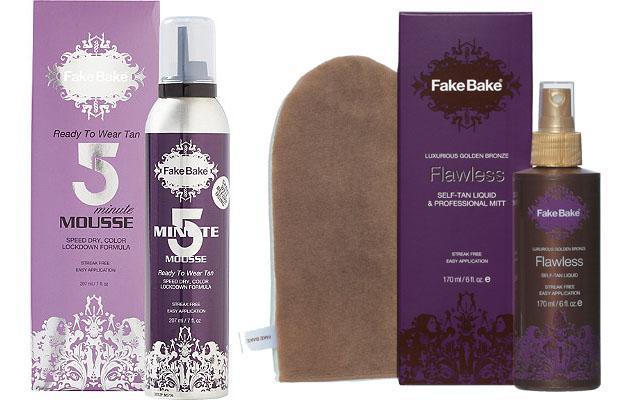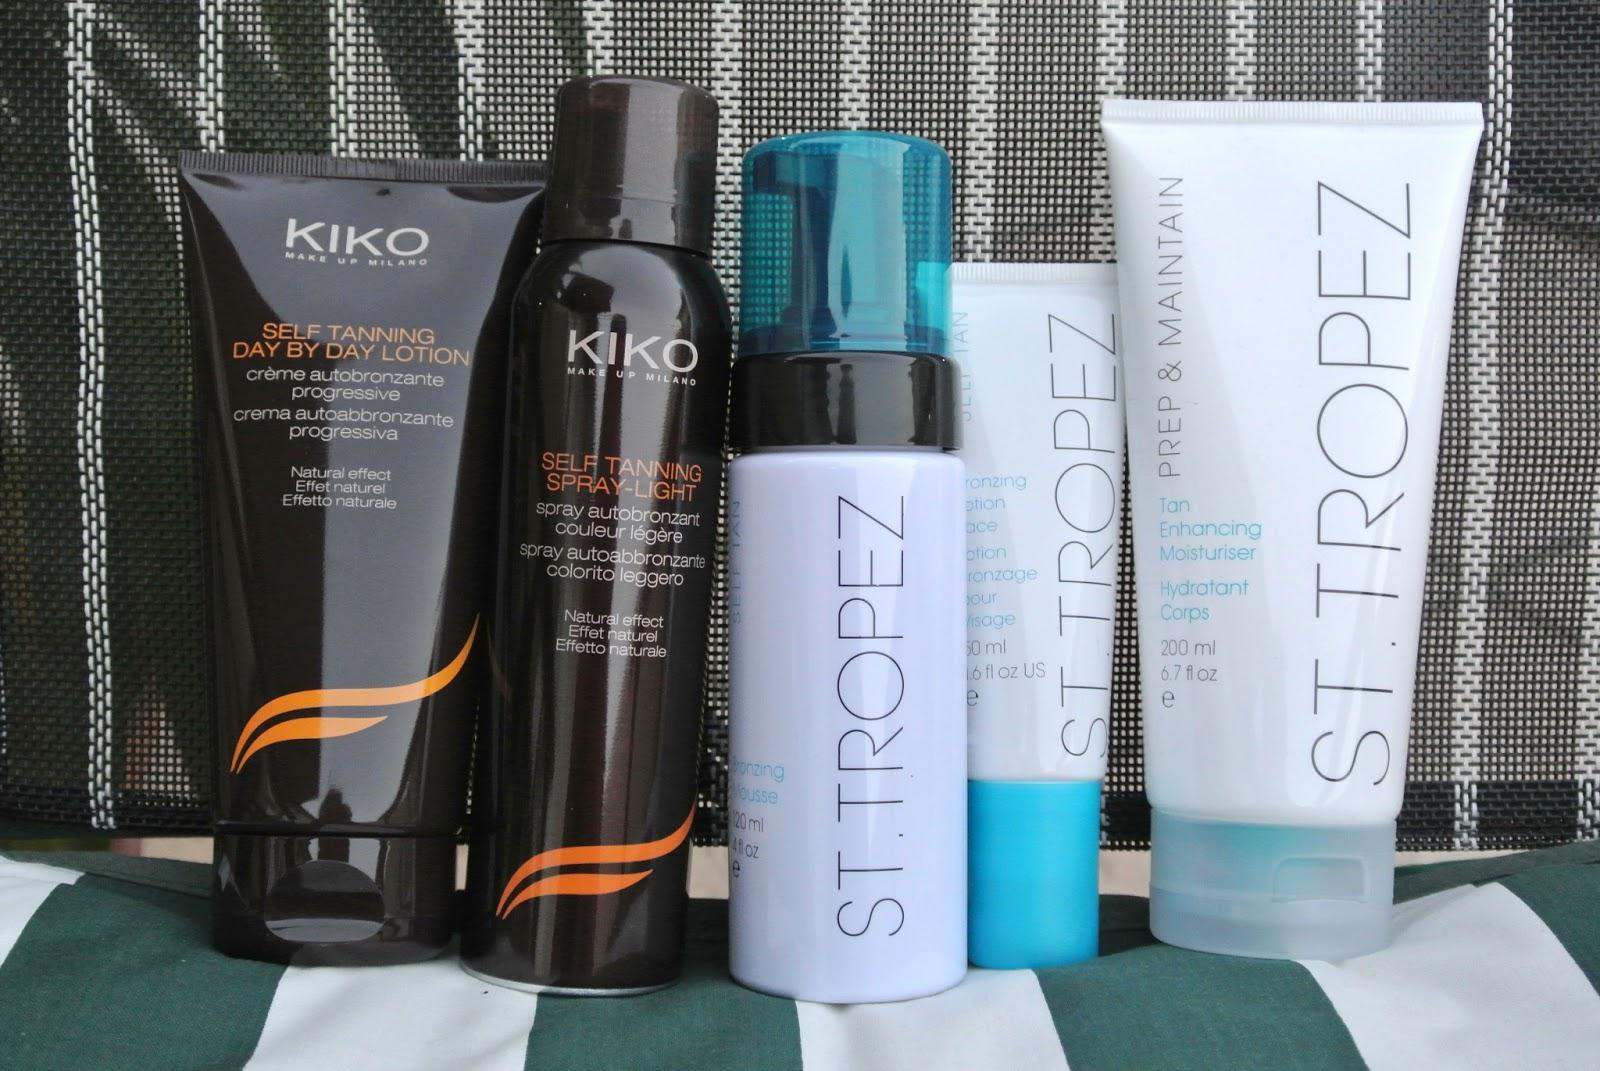The first image is the image on the left, the second image is the image on the right. Assess this claim about the two images: "Two containers stand together in the image on the left.". Correct or not? Answer yes or no. No. The first image is the image on the left, the second image is the image on the right. Evaluate the accuracy of this statement regarding the images: "An image contains only two side-by-side products, which feature green in the packaging.". Is it true? Answer yes or no. No. 